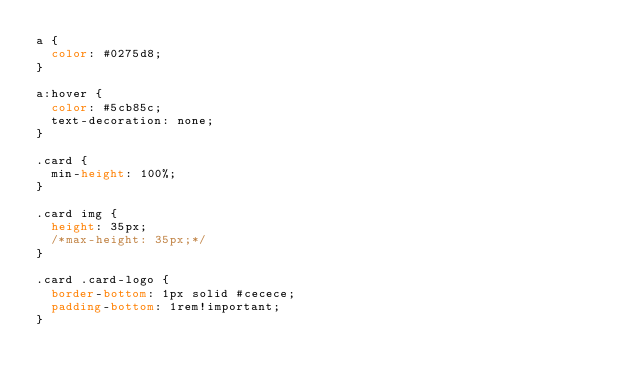Convert code to text. <code><loc_0><loc_0><loc_500><loc_500><_CSS_>a {
  color: #0275d8;
}

a:hover {
  color: #5cb85c;
  text-decoration: none;
}

.card {
  min-height: 100%;
}

.card img {
  height: 35px;
  /*max-height: 35px;*/
}

.card .card-logo {
  border-bottom: 1px solid #cecece;
  padding-bottom: 1rem!important;
}
</code> 